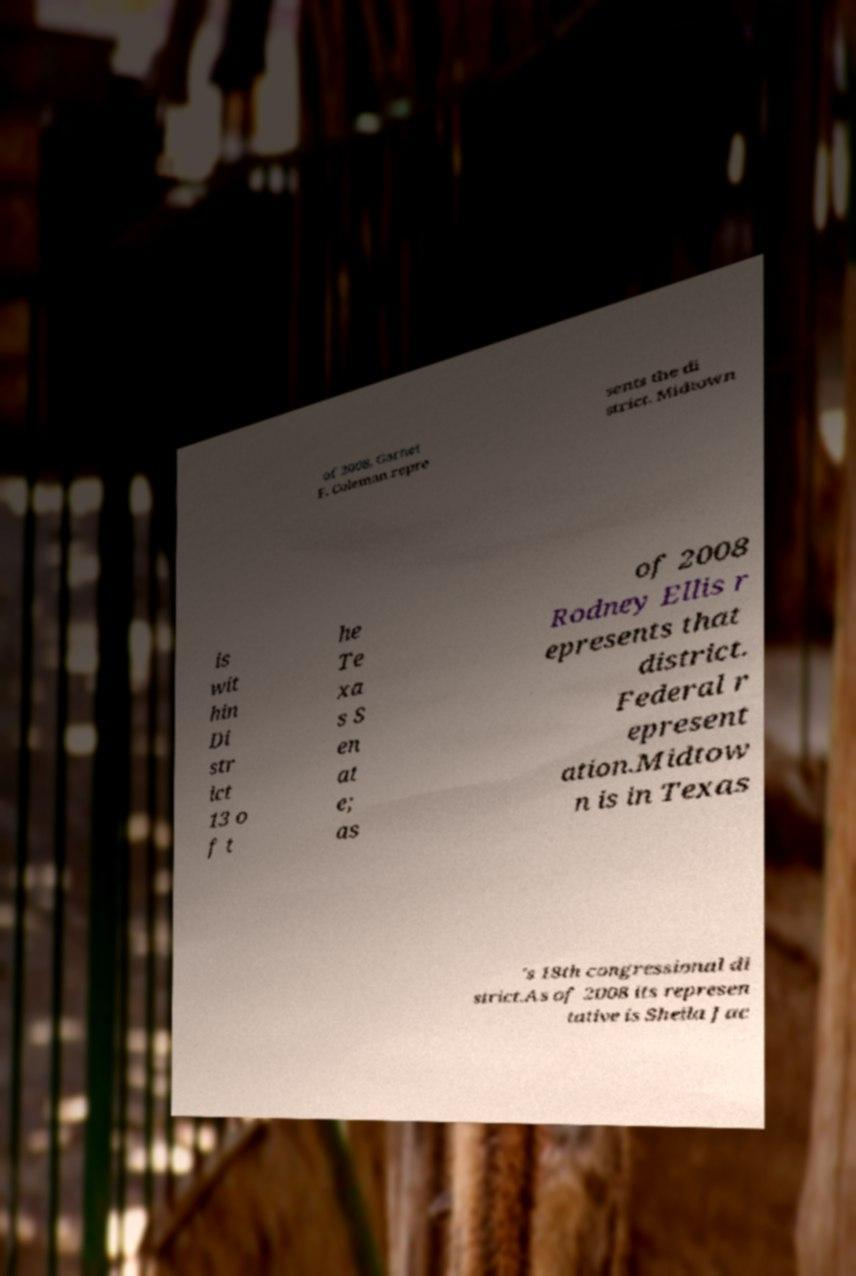Could you assist in decoding the text presented in this image and type it out clearly? of 2008, Garnet F. Coleman repre sents the di strict. Midtown is wit hin Di str ict 13 o f t he Te xa s S en at e; as of 2008 Rodney Ellis r epresents that district. Federal r epresent ation.Midtow n is in Texas 's 18th congressional di strict.As of 2008 its represen tative is Sheila Jac 